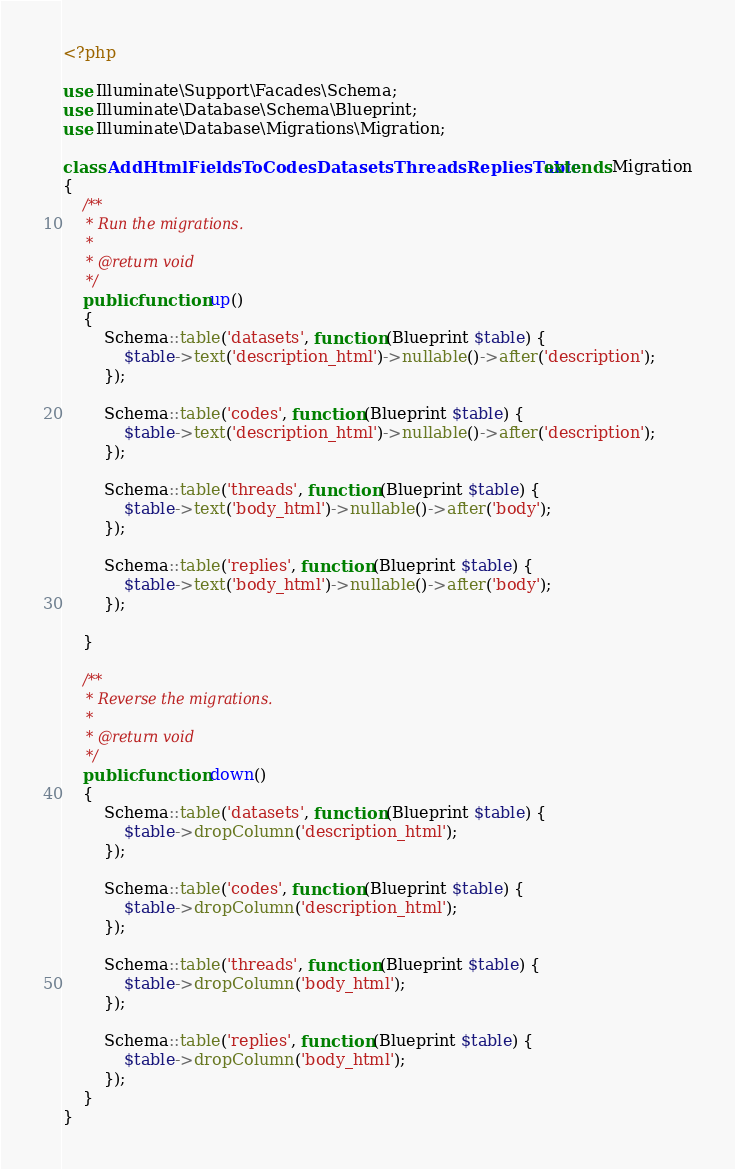Convert code to text. <code><loc_0><loc_0><loc_500><loc_500><_PHP_><?php

use Illuminate\Support\Facades\Schema;
use Illuminate\Database\Schema\Blueprint;
use Illuminate\Database\Migrations\Migration;

class AddHtmlFieldsToCodesDatasetsThreadsRepliesTable extends Migration
{
    /**
     * Run the migrations.
     *
     * @return void
     */
    public function up()
    {
        Schema::table('datasets', function (Blueprint $table) {
            $table->text('description_html')->nullable()->after('description');
        });

        Schema::table('codes', function (Blueprint $table) {
            $table->text('description_html')->nullable()->after('description');
        });

        Schema::table('threads', function (Blueprint $table) {
            $table->text('body_html')->nullable()->after('body');
        });

        Schema::table('replies', function (Blueprint $table) {
            $table->text('body_html')->nullable()->after('body');
        });

    }

    /**
     * Reverse the migrations.
     *
     * @return void
     */
    public function down()
    {
        Schema::table('datasets', function (Blueprint $table) {
            $table->dropColumn('description_html');
        });

        Schema::table('codes', function (Blueprint $table) {
            $table->dropColumn('description_html');
        });

        Schema::table('threads', function (Blueprint $table) {
            $table->dropColumn('body_html');
        });

        Schema::table('replies', function (Blueprint $table) {
            $table->dropColumn('body_html');
        });
    }
}
</code> 